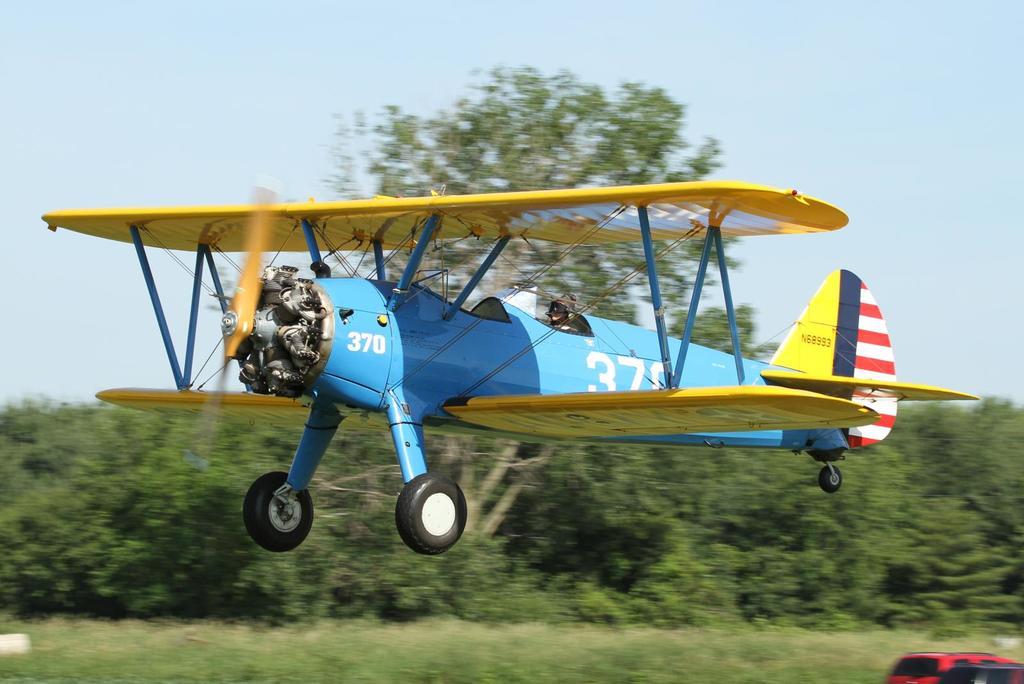What number is the plane?
Offer a terse response. 370. 